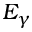Convert formula to latex. <formula><loc_0><loc_0><loc_500><loc_500>E _ { \gamma }</formula> 